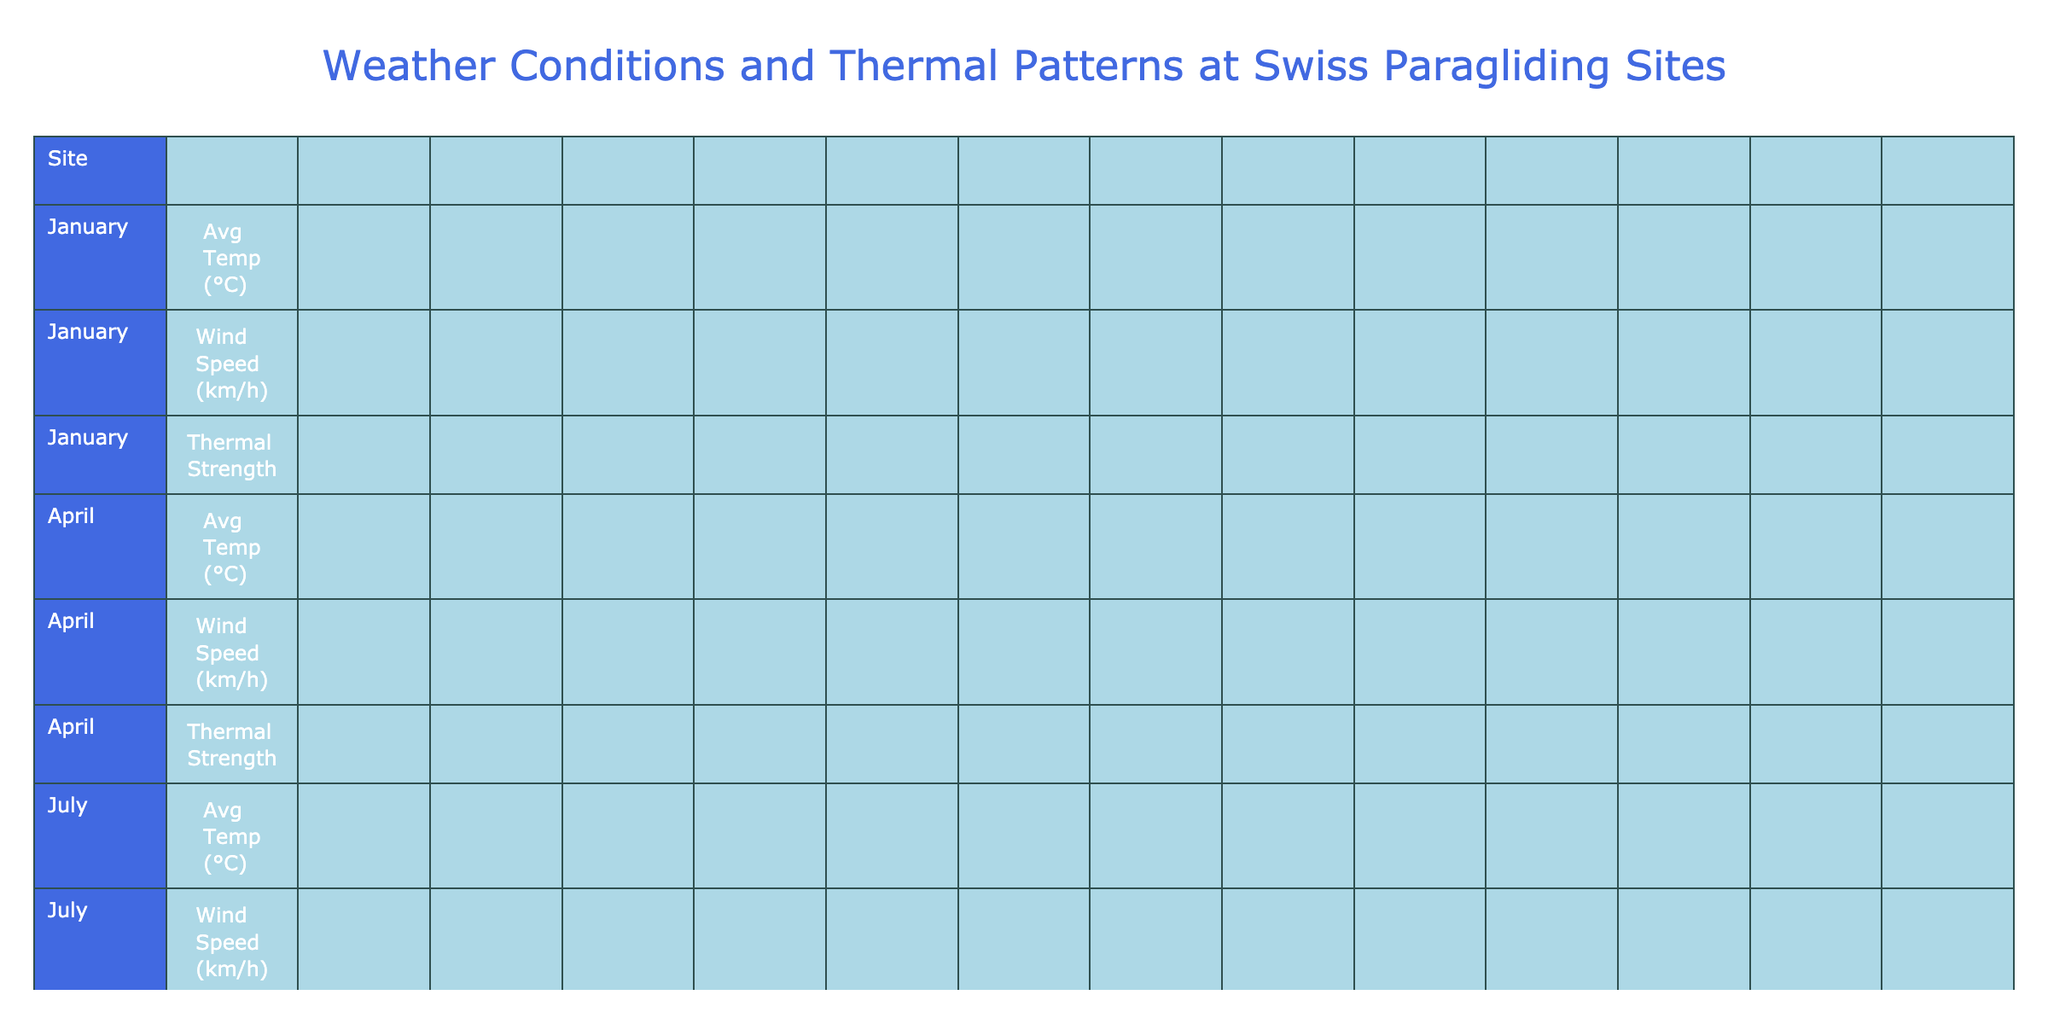What is the average thermal strength in July for all sites? The table lists the thermal strength for July at each site: Strong (Fiesch, Interlaken, Davos, Verbier, Kandersteg), Strong (Zermatt, Engelberg, Grindelwald, Villeneuve, Chur). There are 10 total sites, with 9 classified as Strong and 1 as Moderate (Zermatt). Therefore, the average thermal strength is categorized as Strong.
Answer: Strong Which site has the highest average temperature in April? In the table, the average temperatures for April are listed for each site: Fiesch (8°C), Interlaken (11°C), Davos (5°C), Verbier (7°C), Zermatt (4°C), Engelberg (6°C), Grindelwald (6°C), Villeneuve (12°C), Chur (10°C), Kandersteg (7°C). Villeneuve has the highest value at 12°C.
Answer: Villeneuve Is the wind speed in October higher than in January for any site? The wind speeds for October are listed: Fiesch (14 km/h), Interlaken (11 km/h), Davos (16 km/h), Verbier (15 km/h), Zermatt (13 km/h), Engelberg (14 km/h), Grindelwald (15 km/h), Villeneuve (10 km/h), Chur (13 km/h), Kandersteg (15 km/h). Comparing these with January values: Fiesch (10 km/h), Interlaken (8 km/h), Davos (12 km/h), Verbier (11 km/h), Zermatt (9 km/h), Engelberg (10 km/h), Grindelwald (11 km/h), Villeneuve (7 km/h), Chur (9 km/h), Kandersteg (10 km/h). Davos, Zermatt, and Engelberg all have higher wind speeds in October than in January.
Answer: Yes What is the total annual rainfall for Fiesch compared to Zermatt? Fiesch's annual rainfall is 1100 mm, while Zermatt's is 700 mm. The difference is calculated as 1100 mm - 700 mm = 400 mm, indicating that Fiesch receives more rainfall.
Answer: Fiesch has 400 mm more rainfall than Zermatt Which site has the weakest thermal strength in January? The thermal strength in January is categorized as Weak for all sites listed. Therefore, all sites have the same level of thermal strength in January.
Answer: All sites have Weak thermal strength in January What is the best season for paragliding at Davos? The table indicates that the best season for Davos is Summer. This is consistent across all sites as shown in the Best Season column.
Answer: Summer What is the average wind speed in July across all sites? The July wind speeds are: Fiesch (12 km/h), Interlaken (10 km/h), Davos (14 km/h), Verbier (13 km/h), Zermatt (11 km/h), Engelberg (12 km/h), Grindelwald (13 km/h), Villeneuve (9 km/h), Chur (11 km/h), Kandersteg (13 km/h). Summing these gives 130 km/h and dividing by 10 total sites results in an average of 13 km/h.
Answer: 13 km/h Does Engelberg have a higher average temperature in July than Verbier? Engelberg's average temperature in July is 16°C, while Verbier's is 17°C. Since 16°C < 17°C, Engelberg does not have a higher average temperature.
Answer: No Which site experiences moderate thermal strength in April but weak thermal strength in January? All sites listed have moderate thermal strength in April and weak thermal strength in January. Thus, all sites meet this criterion.
Answer: All sites How does the average temperature in October compare between Fiesch and Interlaken? Fiesch has an average temperature of 10°C, while Interlaken has an average of 12°C. Since 10°C < 12°C, Interlaken has a higher average temperature in October.
Answer: Interlaken is higher 